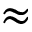<formula> <loc_0><loc_0><loc_500><loc_500>\approx</formula> 